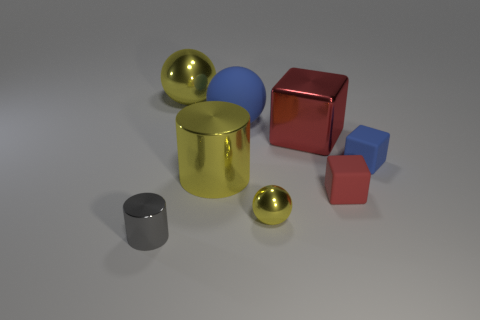Are there more large blue balls than big red metallic spheres?
Ensure brevity in your answer.  Yes. Is there any other thing that is the same color as the tiny cylinder?
Keep it short and to the point. No. There is a tiny gray thing that is made of the same material as the big red object; what shape is it?
Give a very brief answer. Cylinder. What is the big cylinder on the left side of the sphere in front of the tiny red rubber cube made of?
Your answer should be very brief. Metal. There is a big metal thing that is on the right side of the big blue thing; is it the same shape as the small red matte thing?
Offer a very short reply. Yes. Are there more metallic objects that are left of the large block than large cylinders?
Give a very brief answer. Yes. There is another rubber object that is the same color as the big matte thing; what is its shape?
Offer a very short reply. Cube. What number of cubes are yellow objects or gray things?
Give a very brief answer. 0. What is the color of the metallic thing to the right of the yellow ball in front of the small red block?
Ensure brevity in your answer.  Red. Does the large shiny cylinder have the same color as the metallic cylinder in front of the red matte thing?
Give a very brief answer. No. 